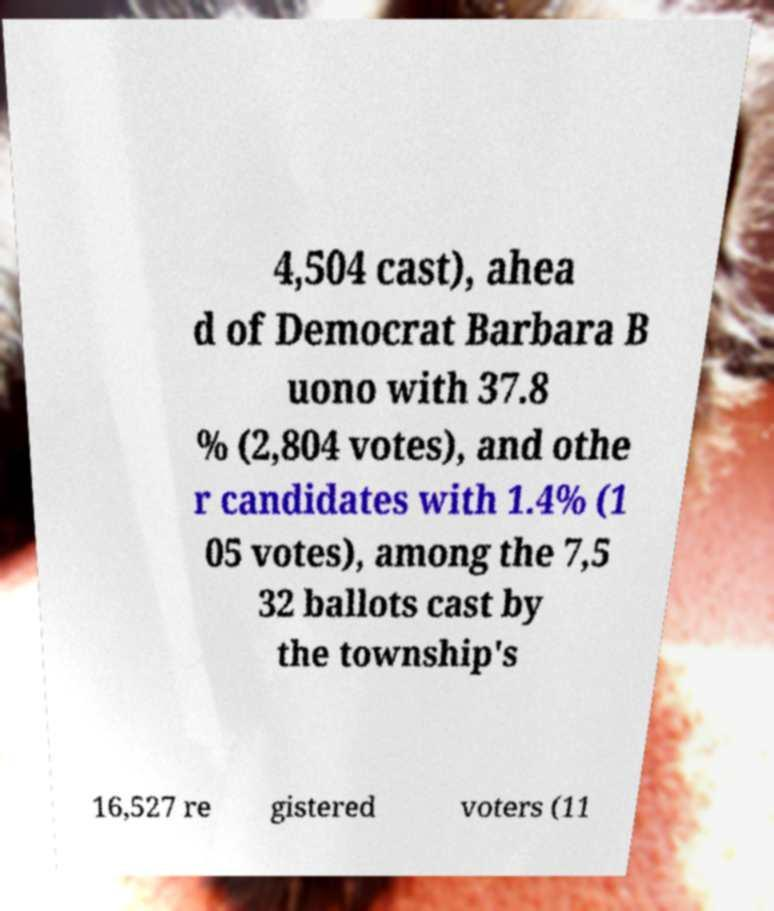Could you assist in decoding the text presented in this image and type it out clearly? 4,504 cast), ahea d of Democrat Barbara B uono with 37.8 % (2,804 votes), and othe r candidates with 1.4% (1 05 votes), among the 7,5 32 ballots cast by the township's 16,527 re gistered voters (11 